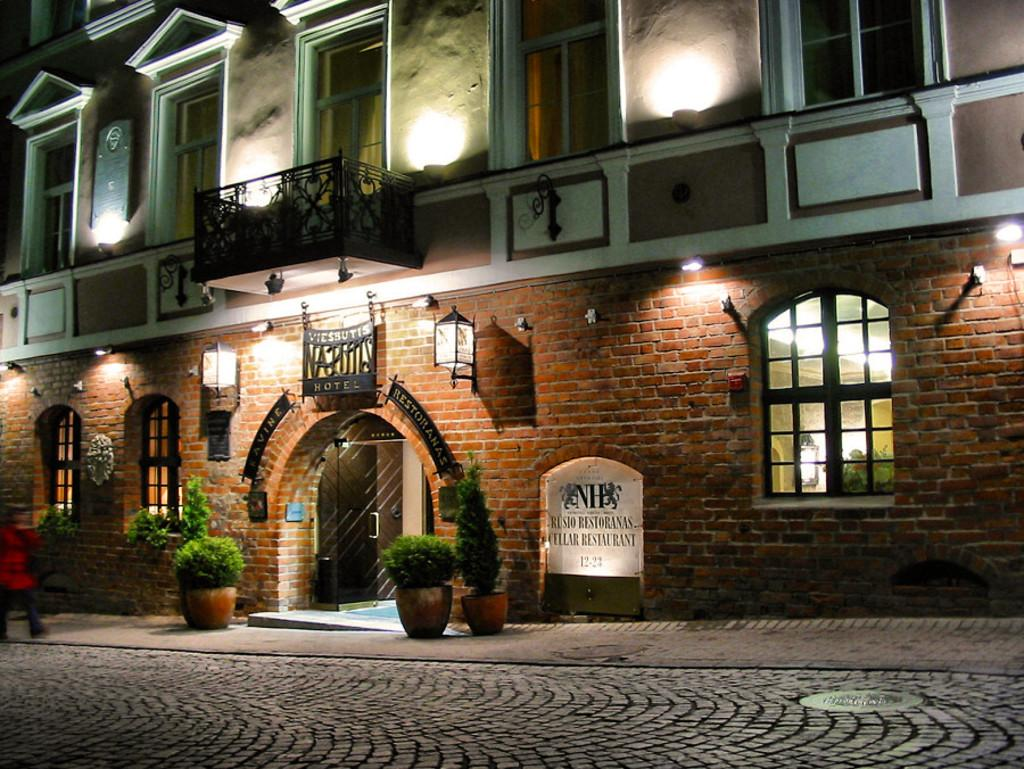<image>
Create a compact narrative representing the image presented. A brick motel several stories tall called Viessutis. 